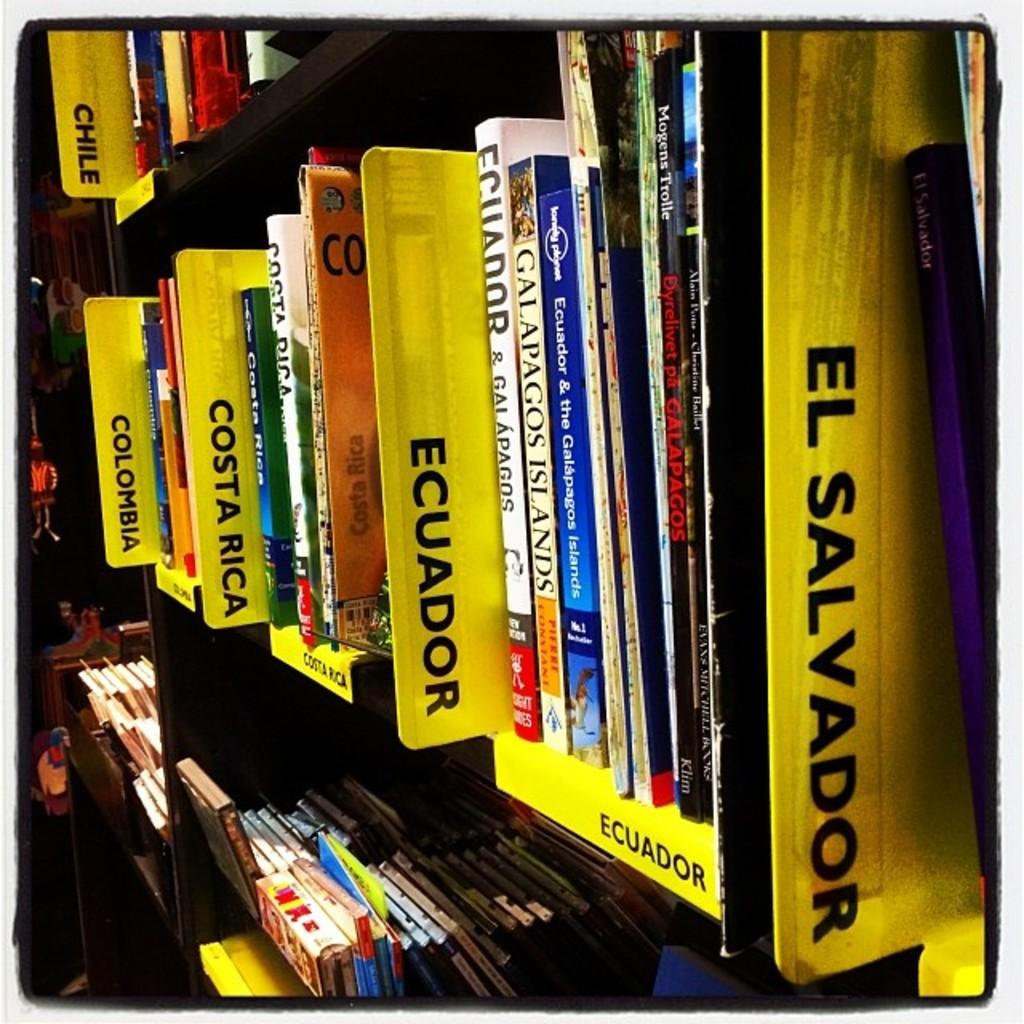<image>
Write a terse but informative summary of the picture. a book  shelf with colombia, costa rica, ecuador 